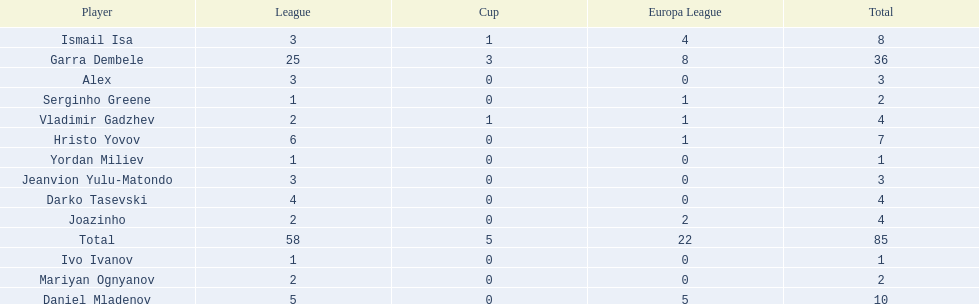Who are all of the players? Garra Dembele, Daniel Mladenov, Ismail Isa, Hristo Yovov, Joazinho, Vladimir Gadzhev, Darko Tasevski, Alex, Jeanvion Yulu-Matondo, Mariyan Ognyanov, Serginho Greene, Yordan Miliev, Ivo Ivanov. And which league is each player in? 25, 5, 3, 6, 2, 2, 4, 3, 3, 2, 1, 1, 1. Along with vladimir gadzhev and joazinho, which other player is in league 2? Mariyan Ognyanov. 